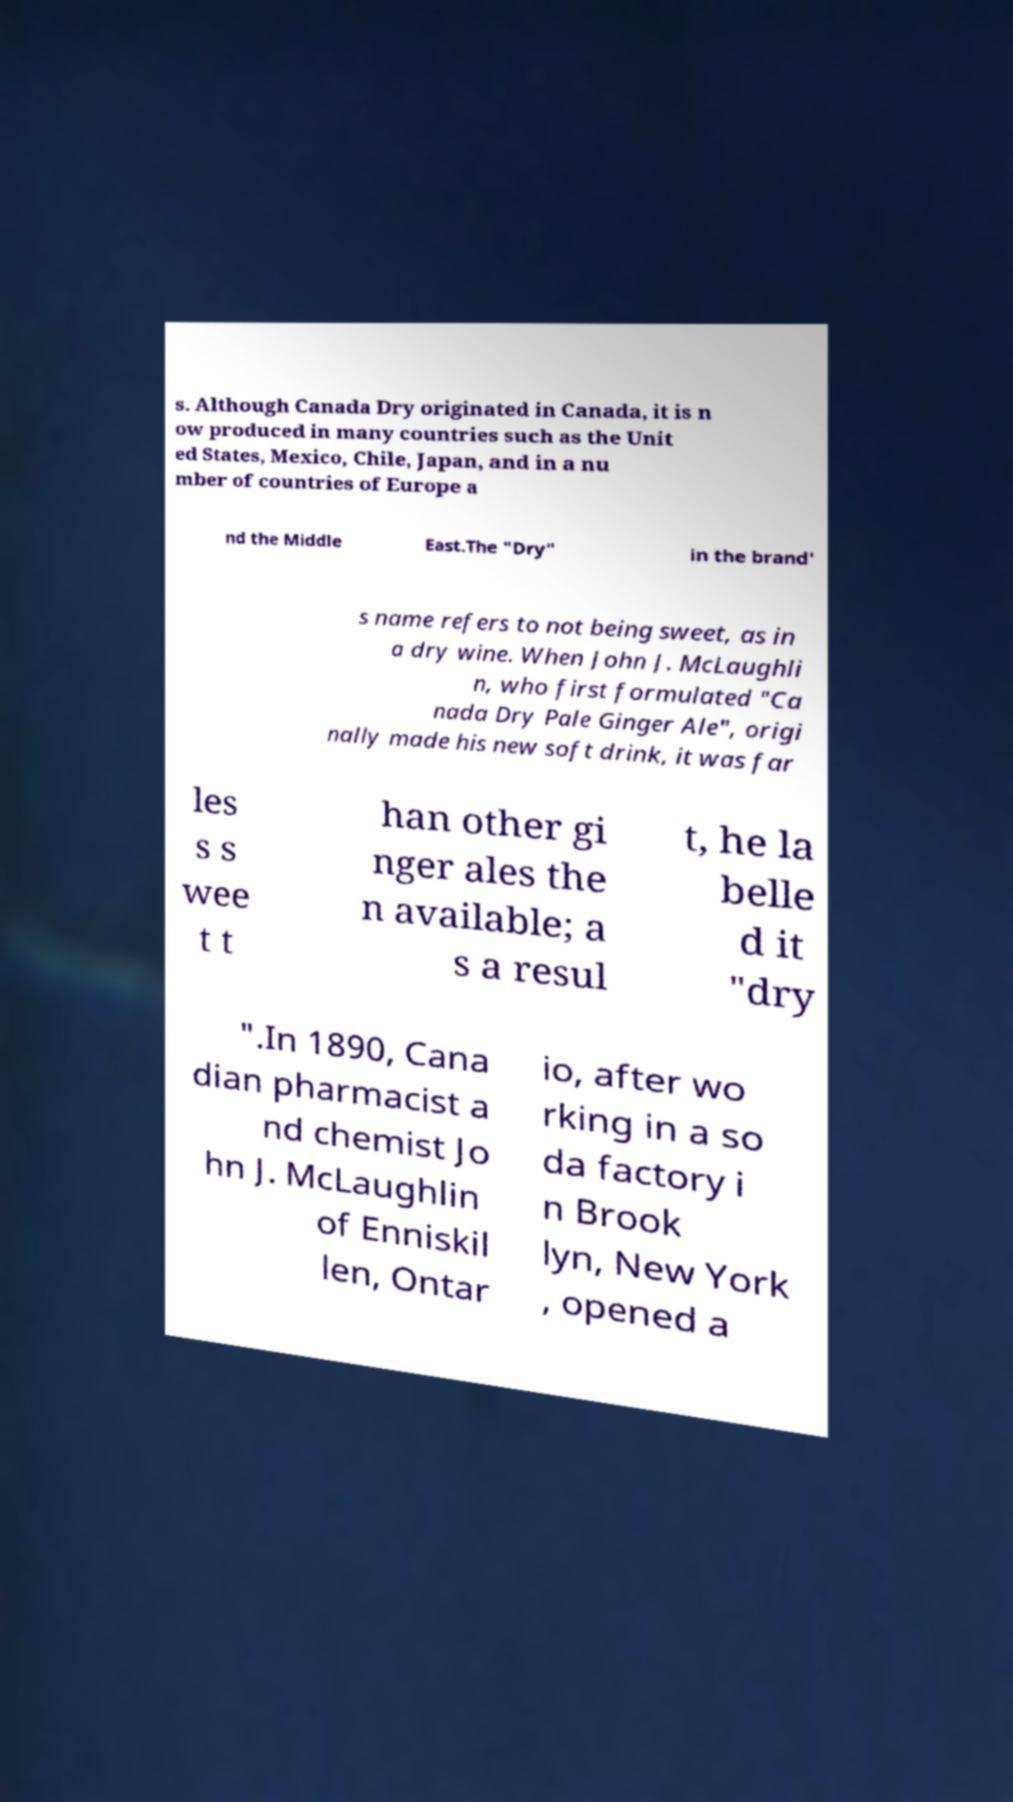There's text embedded in this image that I need extracted. Can you transcribe it verbatim? s. Although Canada Dry originated in Canada, it is n ow produced in many countries such as the Unit ed States, Mexico, Chile, Japan, and in a nu mber of countries of Europe a nd the Middle East.The "Dry" in the brand' s name refers to not being sweet, as in a dry wine. When John J. McLaughli n, who first formulated "Ca nada Dry Pale Ginger Ale", origi nally made his new soft drink, it was far les s s wee t t han other gi nger ales the n available; a s a resul t, he la belle d it "dry ".In 1890, Cana dian pharmacist a nd chemist Jo hn J. McLaughlin of Enniskil len, Ontar io, after wo rking in a so da factory i n Brook lyn, New York , opened a 